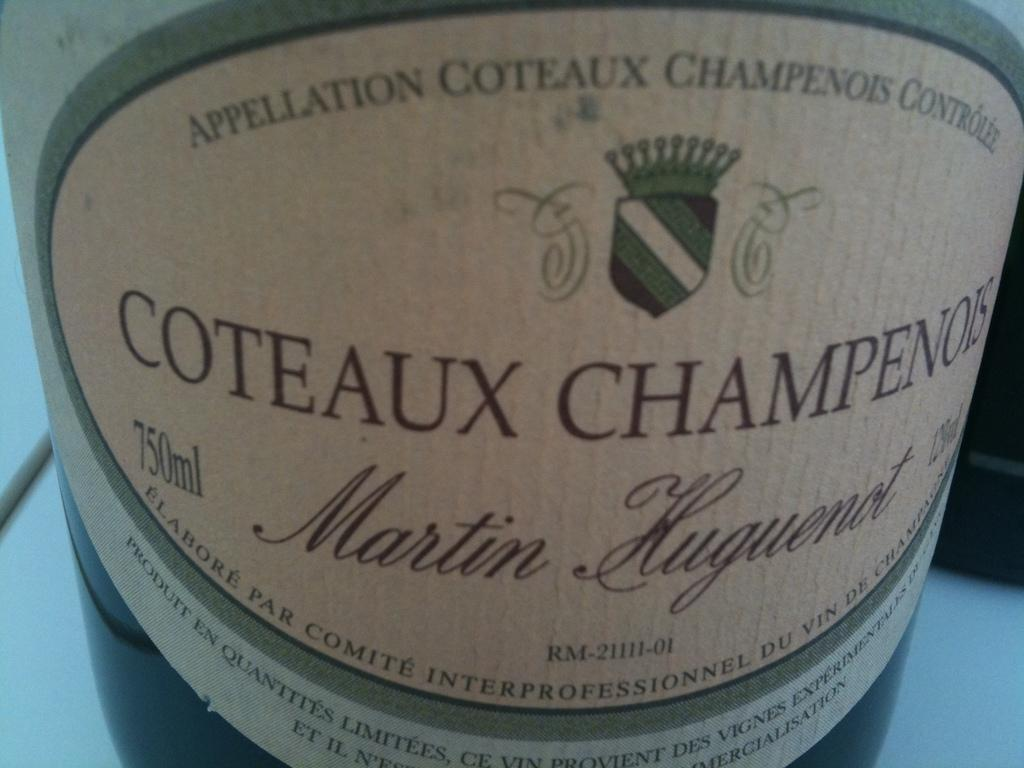<image>
Share a concise interpretation of the image provided. A Martin Huguenot Coteaux Champenois label doesn't show the vintage year. 